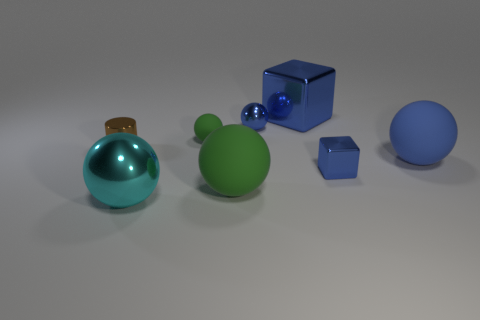Subtract all large cyan spheres. How many spheres are left? 4 Subtract 4 spheres. How many spheres are left? 1 Add 1 tiny cyan metallic blocks. How many objects exist? 9 Subtract all blue balls. How many balls are left? 3 Subtract all blue cubes. How many green balls are left? 2 Subtract all blue balls. Subtract all tiny brown shiny objects. How many objects are left? 5 Add 7 cyan balls. How many cyan balls are left? 8 Add 6 brown cylinders. How many brown cylinders exist? 7 Subtract 0 brown cubes. How many objects are left? 8 Subtract all cylinders. How many objects are left? 7 